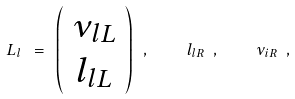<formula> <loc_0><loc_0><loc_500><loc_500>L _ { l } \ = \ \left ( \begin{array} { c } \nu _ { l L } \\ l _ { l L } \end{array} \right ) \ , \quad l _ { l R } \ , \quad \nu _ { i R } \ ,</formula> 